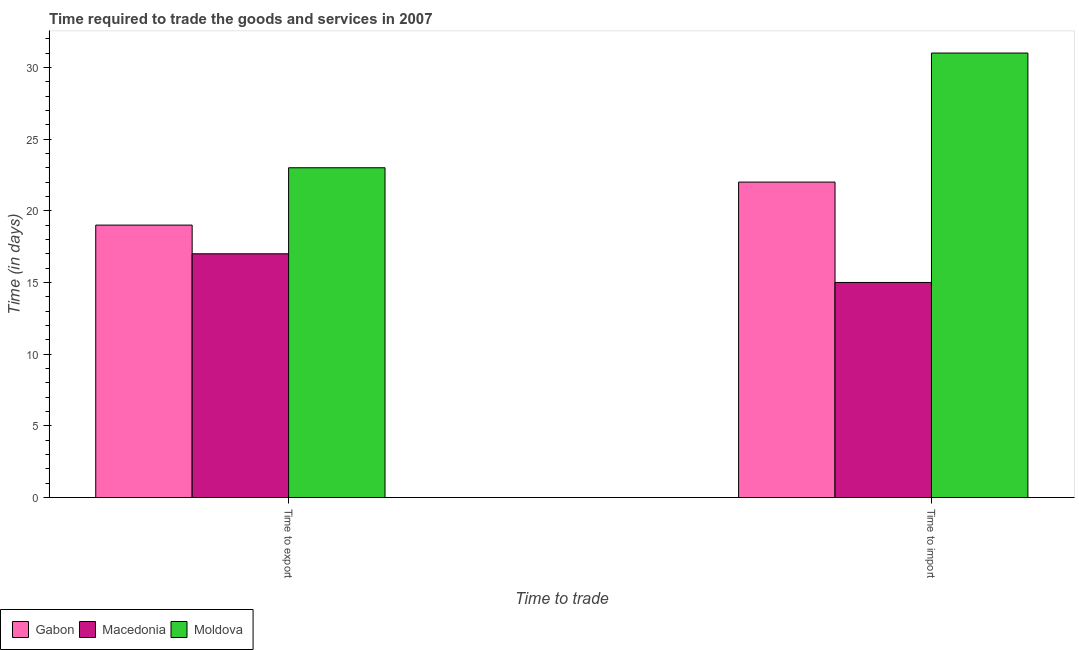How many groups of bars are there?
Your answer should be very brief. 2. How many bars are there on the 2nd tick from the right?
Ensure brevity in your answer.  3. What is the label of the 2nd group of bars from the left?
Make the answer very short. Time to import. What is the time to export in Macedonia?
Ensure brevity in your answer.  17. Across all countries, what is the maximum time to import?
Your answer should be very brief. 31. Across all countries, what is the minimum time to import?
Your response must be concise. 15. In which country was the time to import maximum?
Offer a very short reply. Moldova. In which country was the time to export minimum?
Your answer should be very brief. Macedonia. What is the total time to export in the graph?
Your answer should be compact. 59. What is the difference between the time to import in Gabon and that in Macedonia?
Your answer should be very brief. 7. What is the difference between the time to export in Gabon and the time to import in Macedonia?
Your answer should be compact. 4. What is the average time to export per country?
Your answer should be very brief. 19.67. What is the difference between the time to export and time to import in Gabon?
Ensure brevity in your answer.  -3. In how many countries, is the time to import greater than 2 days?
Offer a terse response. 3. What is the ratio of the time to import in Macedonia to that in Gabon?
Offer a very short reply. 0.68. Is the time to export in Macedonia less than that in Gabon?
Offer a terse response. Yes. In how many countries, is the time to import greater than the average time to import taken over all countries?
Your answer should be very brief. 1. What does the 1st bar from the left in Time to import represents?
Your response must be concise. Gabon. What does the 1st bar from the right in Time to import represents?
Ensure brevity in your answer.  Moldova. How many bars are there?
Offer a very short reply. 6. Are all the bars in the graph horizontal?
Ensure brevity in your answer.  No. Does the graph contain any zero values?
Your answer should be compact. No. Does the graph contain grids?
Your response must be concise. No. Where does the legend appear in the graph?
Keep it short and to the point. Bottom left. How many legend labels are there?
Offer a terse response. 3. What is the title of the graph?
Your response must be concise. Time required to trade the goods and services in 2007. What is the label or title of the X-axis?
Your response must be concise. Time to trade. What is the label or title of the Y-axis?
Keep it short and to the point. Time (in days). What is the Time (in days) in Gabon in Time to export?
Your response must be concise. 19. What is the Time (in days) of Macedonia in Time to export?
Give a very brief answer. 17. What is the Time (in days) of Moldova in Time to export?
Provide a short and direct response. 23. What is the Time (in days) in Gabon in Time to import?
Provide a short and direct response. 22. Across all Time to trade, what is the maximum Time (in days) of Moldova?
Make the answer very short. 31. Across all Time to trade, what is the minimum Time (in days) of Macedonia?
Your answer should be compact. 15. Across all Time to trade, what is the minimum Time (in days) of Moldova?
Give a very brief answer. 23. What is the difference between the Time (in days) in Macedonia in Time to export and that in Time to import?
Your answer should be compact. 2. What is the difference between the Time (in days) of Gabon in Time to export and the Time (in days) of Macedonia in Time to import?
Make the answer very short. 4. What is the difference between the Time (in days) in Gabon in Time to export and the Time (in days) in Moldova in Time to import?
Make the answer very short. -12. What is the average Time (in days) of Gabon per Time to trade?
Ensure brevity in your answer.  20.5. What is the average Time (in days) in Moldova per Time to trade?
Offer a very short reply. 27. What is the difference between the Time (in days) in Gabon and Time (in days) in Moldova in Time to export?
Ensure brevity in your answer.  -4. What is the difference between the Time (in days) of Gabon and Time (in days) of Macedonia in Time to import?
Keep it short and to the point. 7. What is the difference between the Time (in days) of Gabon and Time (in days) of Moldova in Time to import?
Offer a very short reply. -9. What is the ratio of the Time (in days) of Gabon in Time to export to that in Time to import?
Provide a short and direct response. 0.86. What is the ratio of the Time (in days) in Macedonia in Time to export to that in Time to import?
Ensure brevity in your answer.  1.13. What is the ratio of the Time (in days) of Moldova in Time to export to that in Time to import?
Offer a terse response. 0.74. What is the difference between the highest and the second highest Time (in days) in Gabon?
Offer a very short reply. 3. What is the difference between the highest and the second highest Time (in days) in Macedonia?
Ensure brevity in your answer.  2. What is the difference between the highest and the lowest Time (in days) in Macedonia?
Make the answer very short. 2. 